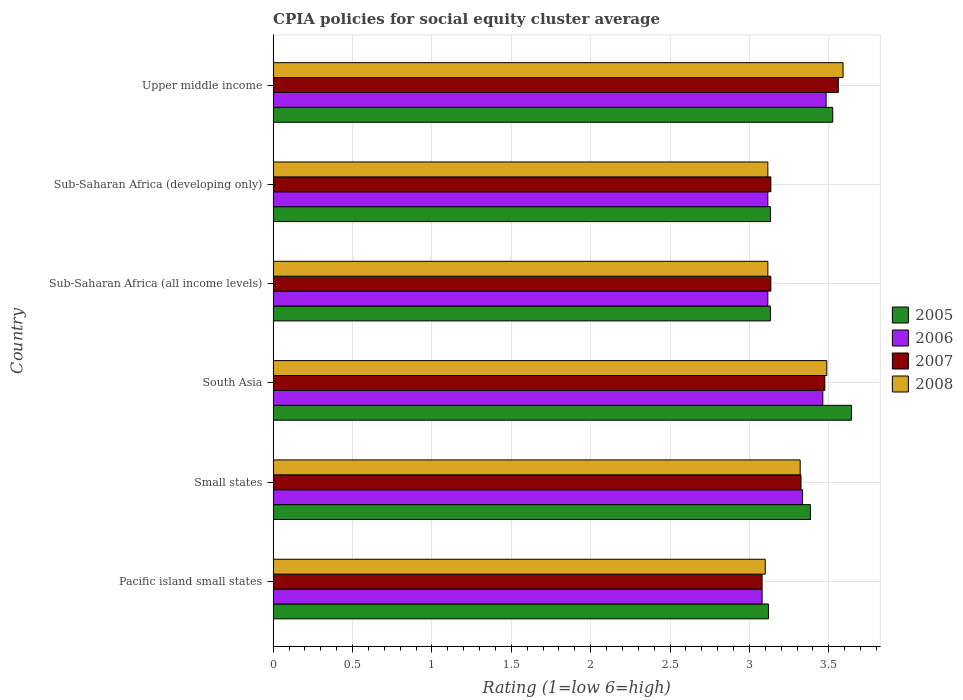How many different coloured bars are there?
Keep it short and to the point. 4. How many groups of bars are there?
Your answer should be compact. 6. Are the number of bars per tick equal to the number of legend labels?
Your response must be concise. Yes. How many bars are there on the 2nd tick from the top?
Give a very brief answer. 4. How many bars are there on the 5th tick from the bottom?
Offer a very short reply. 4. What is the label of the 1st group of bars from the top?
Provide a short and direct response. Upper middle income. What is the CPIA rating in 2007 in Small states?
Give a very brief answer. 3.33. Across all countries, what is the maximum CPIA rating in 2008?
Give a very brief answer. 3.59. Across all countries, what is the minimum CPIA rating in 2006?
Give a very brief answer. 3.08. In which country was the CPIA rating in 2006 maximum?
Offer a terse response. Upper middle income. In which country was the CPIA rating in 2005 minimum?
Make the answer very short. Pacific island small states. What is the total CPIA rating in 2005 in the graph?
Your answer should be very brief. 19.94. What is the difference between the CPIA rating in 2006 in Sub-Saharan Africa (developing only) and that in Upper middle income?
Make the answer very short. -0.37. What is the difference between the CPIA rating in 2005 in South Asia and the CPIA rating in 2006 in Sub-Saharan Africa (developing only)?
Ensure brevity in your answer.  0.53. What is the average CPIA rating in 2008 per country?
Provide a succinct answer. 3.29. What is the difference between the CPIA rating in 2005 and CPIA rating in 2008 in Small states?
Keep it short and to the point. 0.06. In how many countries, is the CPIA rating in 2006 greater than 2.7 ?
Your answer should be compact. 6. What is the ratio of the CPIA rating in 2005 in Small states to that in Sub-Saharan Africa (developing only)?
Ensure brevity in your answer.  1.08. Is the difference between the CPIA rating in 2005 in Pacific island small states and Upper middle income greater than the difference between the CPIA rating in 2008 in Pacific island small states and Upper middle income?
Give a very brief answer. Yes. What is the difference between the highest and the second highest CPIA rating in 2008?
Your answer should be very brief. 0.1. What is the difference between the highest and the lowest CPIA rating in 2005?
Your answer should be compact. 0.52. What does the 4th bar from the top in Pacific island small states represents?
Ensure brevity in your answer.  2005. How many countries are there in the graph?
Provide a short and direct response. 6. Does the graph contain any zero values?
Your response must be concise. No. Does the graph contain grids?
Provide a succinct answer. Yes. How are the legend labels stacked?
Offer a terse response. Vertical. What is the title of the graph?
Give a very brief answer. CPIA policies for social equity cluster average. Does "2003" appear as one of the legend labels in the graph?
Provide a succinct answer. No. What is the label or title of the Y-axis?
Provide a short and direct response. Country. What is the Rating (1=low 6=high) in 2005 in Pacific island small states?
Offer a terse response. 3.12. What is the Rating (1=low 6=high) in 2006 in Pacific island small states?
Ensure brevity in your answer.  3.08. What is the Rating (1=low 6=high) in 2007 in Pacific island small states?
Offer a very short reply. 3.08. What is the Rating (1=low 6=high) in 2005 in Small states?
Offer a terse response. 3.38. What is the Rating (1=low 6=high) in 2006 in Small states?
Offer a terse response. 3.33. What is the Rating (1=low 6=high) of 2007 in Small states?
Make the answer very short. 3.33. What is the Rating (1=low 6=high) in 2008 in Small states?
Keep it short and to the point. 3.32. What is the Rating (1=low 6=high) of 2005 in South Asia?
Ensure brevity in your answer.  3.64. What is the Rating (1=low 6=high) in 2006 in South Asia?
Keep it short and to the point. 3.46. What is the Rating (1=low 6=high) in 2007 in South Asia?
Your answer should be compact. 3.48. What is the Rating (1=low 6=high) of 2008 in South Asia?
Your answer should be very brief. 3.49. What is the Rating (1=low 6=high) of 2005 in Sub-Saharan Africa (all income levels)?
Provide a short and direct response. 3.13. What is the Rating (1=low 6=high) in 2006 in Sub-Saharan Africa (all income levels)?
Ensure brevity in your answer.  3.12. What is the Rating (1=low 6=high) of 2007 in Sub-Saharan Africa (all income levels)?
Offer a terse response. 3.14. What is the Rating (1=low 6=high) in 2008 in Sub-Saharan Africa (all income levels)?
Offer a terse response. 3.12. What is the Rating (1=low 6=high) in 2005 in Sub-Saharan Africa (developing only)?
Keep it short and to the point. 3.13. What is the Rating (1=low 6=high) of 2006 in Sub-Saharan Africa (developing only)?
Your answer should be compact. 3.12. What is the Rating (1=low 6=high) of 2007 in Sub-Saharan Africa (developing only)?
Offer a very short reply. 3.14. What is the Rating (1=low 6=high) in 2008 in Sub-Saharan Africa (developing only)?
Keep it short and to the point. 3.12. What is the Rating (1=low 6=high) of 2005 in Upper middle income?
Your response must be concise. 3.52. What is the Rating (1=low 6=high) in 2006 in Upper middle income?
Your answer should be compact. 3.48. What is the Rating (1=low 6=high) of 2007 in Upper middle income?
Your answer should be very brief. 3.56. What is the Rating (1=low 6=high) of 2008 in Upper middle income?
Give a very brief answer. 3.59. Across all countries, what is the maximum Rating (1=low 6=high) in 2005?
Make the answer very short. 3.64. Across all countries, what is the maximum Rating (1=low 6=high) in 2006?
Provide a short and direct response. 3.48. Across all countries, what is the maximum Rating (1=low 6=high) in 2007?
Provide a succinct answer. 3.56. Across all countries, what is the maximum Rating (1=low 6=high) in 2008?
Ensure brevity in your answer.  3.59. Across all countries, what is the minimum Rating (1=low 6=high) in 2005?
Give a very brief answer. 3.12. Across all countries, what is the minimum Rating (1=low 6=high) in 2006?
Provide a short and direct response. 3.08. Across all countries, what is the minimum Rating (1=low 6=high) of 2007?
Your response must be concise. 3.08. What is the total Rating (1=low 6=high) of 2005 in the graph?
Ensure brevity in your answer.  19.94. What is the total Rating (1=low 6=high) of 2006 in the graph?
Your answer should be compact. 19.59. What is the total Rating (1=low 6=high) in 2007 in the graph?
Give a very brief answer. 19.71. What is the total Rating (1=low 6=high) in 2008 in the graph?
Provide a short and direct response. 19.73. What is the difference between the Rating (1=low 6=high) in 2005 in Pacific island small states and that in Small states?
Keep it short and to the point. -0.26. What is the difference between the Rating (1=low 6=high) in 2006 in Pacific island small states and that in Small states?
Provide a succinct answer. -0.26. What is the difference between the Rating (1=low 6=high) in 2007 in Pacific island small states and that in Small states?
Offer a very short reply. -0.24. What is the difference between the Rating (1=low 6=high) in 2008 in Pacific island small states and that in Small states?
Your answer should be very brief. -0.22. What is the difference between the Rating (1=low 6=high) in 2005 in Pacific island small states and that in South Asia?
Offer a terse response. -0.52. What is the difference between the Rating (1=low 6=high) of 2006 in Pacific island small states and that in South Asia?
Provide a short and direct response. -0.38. What is the difference between the Rating (1=low 6=high) in 2007 in Pacific island small states and that in South Asia?
Give a very brief answer. -0.4. What is the difference between the Rating (1=low 6=high) of 2008 in Pacific island small states and that in South Asia?
Keep it short and to the point. -0.39. What is the difference between the Rating (1=low 6=high) of 2005 in Pacific island small states and that in Sub-Saharan Africa (all income levels)?
Your answer should be compact. -0.01. What is the difference between the Rating (1=low 6=high) in 2006 in Pacific island small states and that in Sub-Saharan Africa (all income levels)?
Ensure brevity in your answer.  -0.04. What is the difference between the Rating (1=low 6=high) of 2007 in Pacific island small states and that in Sub-Saharan Africa (all income levels)?
Offer a very short reply. -0.06. What is the difference between the Rating (1=low 6=high) in 2008 in Pacific island small states and that in Sub-Saharan Africa (all income levels)?
Provide a succinct answer. -0.02. What is the difference between the Rating (1=low 6=high) of 2005 in Pacific island small states and that in Sub-Saharan Africa (developing only)?
Your answer should be compact. -0.01. What is the difference between the Rating (1=low 6=high) in 2006 in Pacific island small states and that in Sub-Saharan Africa (developing only)?
Offer a terse response. -0.04. What is the difference between the Rating (1=low 6=high) in 2007 in Pacific island small states and that in Sub-Saharan Africa (developing only)?
Offer a terse response. -0.06. What is the difference between the Rating (1=low 6=high) of 2008 in Pacific island small states and that in Sub-Saharan Africa (developing only)?
Offer a very short reply. -0.02. What is the difference between the Rating (1=low 6=high) of 2005 in Pacific island small states and that in Upper middle income?
Give a very brief answer. -0.41. What is the difference between the Rating (1=low 6=high) in 2006 in Pacific island small states and that in Upper middle income?
Keep it short and to the point. -0.4. What is the difference between the Rating (1=low 6=high) of 2007 in Pacific island small states and that in Upper middle income?
Give a very brief answer. -0.48. What is the difference between the Rating (1=low 6=high) in 2008 in Pacific island small states and that in Upper middle income?
Provide a short and direct response. -0.49. What is the difference between the Rating (1=low 6=high) of 2005 in Small states and that in South Asia?
Your response must be concise. -0.26. What is the difference between the Rating (1=low 6=high) of 2006 in Small states and that in South Asia?
Ensure brevity in your answer.  -0.13. What is the difference between the Rating (1=low 6=high) in 2008 in Small states and that in South Asia?
Give a very brief answer. -0.17. What is the difference between the Rating (1=low 6=high) in 2005 in Small states and that in Sub-Saharan Africa (all income levels)?
Keep it short and to the point. 0.25. What is the difference between the Rating (1=low 6=high) in 2006 in Small states and that in Sub-Saharan Africa (all income levels)?
Provide a short and direct response. 0.22. What is the difference between the Rating (1=low 6=high) in 2007 in Small states and that in Sub-Saharan Africa (all income levels)?
Give a very brief answer. 0.19. What is the difference between the Rating (1=low 6=high) in 2008 in Small states and that in Sub-Saharan Africa (all income levels)?
Offer a very short reply. 0.2. What is the difference between the Rating (1=low 6=high) of 2005 in Small states and that in Sub-Saharan Africa (developing only)?
Keep it short and to the point. 0.25. What is the difference between the Rating (1=low 6=high) of 2006 in Small states and that in Sub-Saharan Africa (developing only)?
Make the answer very short. 0.22. What is the difference between the Rating (1=low 6=high) of 2007 in Small states and that in Sub-Saharan Africa (developing only)?
Provide a succinct answer. 0.19. What is the difference between the Rating (1=low 6=high) in 2008 in Small states and that in Sub-Saharan Africa (developing only)?
Your answer should be very brief. 0.2. What is the difference between the Rating (1=low 6=high) of 2005 in Small states and that in Upper middle income?
Your response must be concise. -0.14. What is the difference between the Rating (1=low 6=high) of 2006 in Small states and that in Upper middle income?
Give a very brief answer. -0.15. What is the difference between the Rating (1=low 6=high) of 2007 in Small states and that in Upper middle income?
Keep it short and to the point. -0.23. What is the difference between the Rating (1=low 6=high) of 2008 in Small states and that in Upper middle income?
Ensure brevity in your answer.  -0.27. What is the difference between the Rating (1=low 6=high) in 2005 in South Asia and that in Sub-Saharan Africa (all income levels)?
Provide a succinct answer. 0.51. What is the difference between the Rating (1=low 6=high) of 2006 in South Asia and that in Sub-Saharan Africa (all income levels)?
Your answer should be compact. 0.35. What is the difference between the Rating (1=low 6=high) in 2007 in South Asia and that in Sub-Saharan Africa (all income levels)?
Provide a short and direct response. 0.34. What is the difference between the Rating (1=low 6=high) in 2008 in South Asia and that in Sub-Saharan Africa (all income levels)?
Ensure brevity in your answer.  0.37. What is the difference between the Rating (1=low 6=high) of 2005 in South Asia and that in Sub-Saharan Africa (developing only)?
Keep it short and to the point. 0.51. What is the difference between the Rating (1=low 6=high) of 2006 in South Asia and that in Sub-Saharan Africa (developing only)?
Provide a short and direct response. 0.35. What is the difference between the Rating (1=low 6=high) of 2007 in South Asia and that in Sub-Saharan Africa (developing only)?
Your response must be concise. 0.34. What is the difference between the Rating (1=low 6=high) in 2008 in South Asia and that in Sub-Saharan Africa (developing only)?
Make the answer very short. 0.37. What is the difference between the Rating (1=low 6=high) in 2005 in South Asia and that in Upper middle income?
Your answer should be compact. 0.12. What is the difference between the Rating (1=low 6=high) in 2006 in South Asia and that in Upper middle income?
Your answer should be compact. -0.02. What is the difference between the Rating (1=low 6=high) of 2007 in South Asia and that in Upper middle income?
Make the answer very short. -0.09. What is the difference between the Rating (1=low 6=high) of 2008 in South Asia and that in Upper middle income?
Keep it short and to the point. -0.1. What is the difference between the Rating (1=low 6=high) in 2006 in Sub-Saharan Africa (all income levels) and that in Sub-Saharan Africa (developing only)?
Your answer should be very brief. 0. What is the difference between the Rating (1=low 6=high) in 2008 in Sub-Saharan Africa (all income levels) and that in Sub-Saharan Africa (developing only)?
Provide a short and direct response. 0. What is the difference between the Rating (1=low 6=high) of 2005 in Sub-Saharan Africa (all income levels) and that in Upper middle income?
Provide a short and direct response. -0.39. What is the difference between the Rating (1=low 6=high) of 2006 in Sub-Saharan Africa (all income levels) and that in Upper middle income?
Offer a terse response. -0.37. What is the difference between the Rating (1=low 6=high) of 2007 in Sub-Saharan Africa (all income levels) and that in Upper middle income?
Your answer should be very brief. -0.42. What is the difference between the Rating (1=low 6=high) in 2008 in Sub-Saharan Africa (all income levels) and that in Upper middle income?
Your response must be concise. -0.47. What is the difference between the Rating (1=low 6=high) of 2005 in Sub-Saharan Africa (developing only) and that in Upper middle income?
Provide a short and direct response. -0.39. What is the difference between the Rating (1=low 6=high) in 2006 in Sub-Saharan Africa (developing only) and that in Upper middle income?
Your answer should be compact. -0.37. What is the difference between the Rating (1=low 6=high) in 2007 in Sub-Saharan Africa (developing only) and that in Upper middle income?
Provide a short and direct response. -0.42. What is the difference between the Rating (1=low 6=high) of 2008 in Sub-Saharan Africa (developing only) and that in Upper middle income?
Offer a very short reply. -0.47. What is the difference between the Rating (1=low 6=high) in 2005 in Pacific island small states and the Rating (1=low 6=high) in 2006 in Small states?
Provide a short and direct response. -0.21. What is the difference between the Rating (1=low 6=high) in 2005 in Pacific island small states and the Rating (1=low 6=high) in 2007 in Small states?
Provide a short and direct response. -0.2. What is the difference between the Rating (1=low 6=high) in 2006 in Pacific island small states and the Rating (1=low 6=high) in 2007 in Small states?
Your answer should be compact. -0.24. What is the difference between the Rating (1=low 6=high) in 2006 in Pacific island small states and the Rating (1=low 6=high) in 2008 in Small states?
Provide a succinct answer. -0.24. What is the difference between the Rating (1=low 6=high) of 2007 in Pacific island small states and the Rating (1=low 6=high) of 2008 in Small states?
Keep it short and to the point. -0.24. What is the difference between the Rating (1=low 6=high) of 2005 in Pacific island small states and the Rating (1=low 6=high) of 2006 in South Asia?
Make the answer very short. -0.34. What is the difference between the Rating (1=low 6=high) of 2005 in Pacific island small states and the Rating (1=low 6=high) of 2007 in South Asia?
Ensure brevity in your answer.  -0.35. What is the difference between the Rating (1=low 6=high) of 2005 in Pacific island small states and the Rating (1=low 6=high) of 2008 in South Asia?
Keep it short and to the point. -0.37. What is the difference between the Rating (1=low 6=high) in 2006 in Pacific island small states and the Rating (1=low 6=high) in 2007 in South Asia?
Ensure brevity in your answer.  -0.4. What is the difference between the Rating (1=low 6=high) in 2006 in Pacific island small states and the Rating (1=low 6=high) in 2008 in South Asia?
Give a very brief answer. -0.41. What is the difference between the Rating (1=low 6=high) in 2007 in Pacific island small states and the Rating (1=low 6=high) in 2008 in South Asia?
Make the answer very short. -0.41. What is the difference between the Rating (1=low 6=high) of 2005 in Pacific island small states and the Rating (1=low 6=high) of 2006 in Sub-Saharan Africa (all income levels)?
Offer a terse response. 0. What is the difference between the Rating (1=low 6=high) of 2005 in Pacific island small states and the Rating (1=low 6=high) of 2007 in Sub-Saharan Africa (all income levels)?
Your response must be concise. -0.02. What is the difference between the Rating (1=low 6=high) in 2005 in Pacific island small states and the Rating (1=low 6=high) in 2008 in Sub-Saharan Africa (all income levels)?
Ensure brevity in your answer.  0. What is the difference between the Rating (1=low 6=high) in 2006 in Pacific island small states and the Rating (1=low 6=high) in 2007 in Sub-Saharan Africa (all income levels)?
Offer a very short reply. -0.06. What is the difference between the Rating (1=low 6=high) of 2006 in Pacific island small states and the Rating (1=low 6=high) of 2008 in Sub-Saharan Africa (all income levels)?
Give a very brief answer. -0.04. What is the difference between the Rating (1=low 6=high) in 2007 in Pacific island small states and the Rating (1=low 6=high) in 2008 in Sub-Saharan Africa (all income levels)?
Provide a short and direct response. -0.04. What is the difference between the Rating (1=low 6=high) in 2005 in Pacific island small states and the Rating (1=low 6=high) in 2006 in Sub-Saharan Africa (developing only)?
Your response must be concise. 0. What is the difference between the Rating (1=low 6=high) of 2005 in Pacific island small states and the Rating (1=low 6=high) of 2007 in Sub-Saharan Africa (developing only)?
Your answer should be compact. -0.02. What is the difference between the Rating (1=low 6=high) of 2005 in Pacific island small states and the Rating (1=low 6=high) of 2008 in Sub-Saharan Africa (developing only)?
Offer a very short reply. 0. What is the difference between the Rating (1=low 6=high) of 2006 in Pacific island small states and the Rating (1=low 6=high) of 2007 in Sub-Saharan Africa (developing only)?
Provide a succinct answer. -0.06. What is the difference between the Rating (1=low 6=high) in 2006 in Pacific island small states and the Rating (1=low 6=high) in 2008 in Sub-Saharan Africa (developing only)?
Your answer should be very brief. -0.04. What is the difference between the Rating (1=low 6=high) of 2007 in Pacific island small states and the Rating (1=low 6=high) of 2008 in Sub-Saharan Africa (developing only)?
Give a very brief answer. -0.04. What is the difference between the Rating (1=low 6=high) of 2005 in Pacific island small states and the Rating (1=low 6=high) of 2006 in Upper middle income?
Your response must be concise. -0.36. What is the difference between the Rating (1=low 6=high) in 2005 in Pacific island small states and the Rating (1=low 6=high) in 2007 in Upper middle income?
Make the answer very short. -0.44. What is the difference between the Rating (1=low 6=high) in 2005 in Pacific island small states and the Rating (1=low 6=high) in 2008 in Upper middle income?
Your answer should be very brief. -0.47. What is the difference between the Rating (1=low 6=high) of 2006 in Pacific island small states and the Rating (1=low 6=high) of 2007 in Upper middle income?
Your response must be concise. -0.48. What is the difference between the Rating (1=low 6=high) of 2006 in Pacific island small states and the Rating (1=low 6=high) of 2008 in Upper middle income?
Offer a terse response. -0.51. What is the difference between the Rating (1=low 6=high) in 2007 in Pacific island small states and the Rating (1=low 6=high) in 2008 in Upper middle income?
Your answer should be very brief. -0.51. What is the difference between the Rating (1=low 6=high) of 2005 in Small states and the Rating (1=low 6=high) of 2006 in South Asia?
Your answer should be very brief. -0.08. What is the difference between the Rating (1=low 6=high) of 2005 in Small states and the Rating (1=low 6=high) of 2007 in South Asia?
Offer a terse response. -0.09. What is the difference between the Rating (1=low 6=high) in 2005 in Small states and the Rating (1=low 6=high) in 2008 in South Asia?
Offer a terse response. -0.1. What is the difference between the Rating (1=low 6=high) in 2006 in Small states and the Rating (1=low 6=high) in 2007 in South Asia?
Provide a short and direct response. -0.14. What is the difference between the Rating (1=low 6=high) in 2006 in Small states and the Rating (1=low 6=high) in 2008 in South Asia?
Provide a succinct answer. -0.15. What is the difference between the Rating (1=low 6=high) in 2007 in Small states and the Rating (1=low 6=high) in 2008 in South Asia?
Offer a very short reply. -0.16. What is the difference between the Rating (1=low 6=high) in 2005 in Small states and the Rating (1=low 6=high) in 2006 in Sub-Saharan Africa (all income levels)?
Your response must be concise. 0.27. What is the difference between the Rating (1=low 6=high) of 2005 in Small states and the Rating (1=low 6=high) of 2007 in Sub-Saharan Africa (all income levels)?
Offer a very short reply. 0.25. What is the difference between the Rating (1=low 6=high) in 2005 in Small states and the Rating (1=low 6=high) in 2008 in Sub-Saharan Africa (all income levels)?
Give a very brief answer. 0.27. What is the difference between the Rating (1=low 6=high) in 2006 in Small states and the Rating (1=low 6=high) in 2007 in Sub-Saharan Africa (all income levels)?
Offer a very short reply. 0.2. What is the difference between the Rating (1=low 6=high) in 2006 in Small states and the Rating (1=low 6=high) in 2008 in Sub-Saharan Africa (all income levels)?
Give a very brief answer. 0.22. What is the difference between the Rating (1=low 6=high) in 2007 in Small states and the Rating (1=low 6=high) in 2008 in Sub-Saharan Africa (all income levels)?
Offer a very short reply. 0.21. What is the difference between the Rating (1=low 6=high) of 2005 in Small states and the Rating (1=low 6=high) of 2006 in Sub-Saharan Africa (developing only)?
Provide a succinct answer. 0.27. What is the difference between the Rating (1=low 6=high) in 2005 in Small states and the Rating (1=low 6=high) in 2007 in Sub-Saharan Africa (developing only)?
Make the answer very short. 0.25. What is the difference between the Rating (1=low 6=high) of 2005 in Small states and the Rating (1=low 6=high) of 2008 in Sub-Saharan Africa (developing only)?
Keep it short and to the point. 0.27. What is the difference between the Rating (1=low 6=high) of 2006 in Small states and the Rating (1=low 6=high) of 2007 in Sub-Saharan Africa (developing only)?
Keep it short and to the point. 0.2. What is the difference between the Rating (1=low 6=high) in 2006 in Small states and the Rating (1=low 6=high) in 2008 in Sub-Saharan Africa (developing only)?
Give a very brief answer. 0.22. What is the difference between the Rating (1=low 6=high) of 2007 in Small states and the Rating (1=low 6=high) of 2008 in Sub-Saharan Africa (developing only)?
Keep it short and to the point. 0.21. What is the difference between the Rating (1=low 6=high) of 2005 in Small states and the Rating (1=low 6=high) of 2006 in Upper middle income?
Provide a succinct answer. -0.1. What is the difference between the Rating (1=low 6=high) in 2005 in Small states and the Rating (1=low 6=high) in 2007 in Upper middle income?
Make the answer very short. -0.18. What is the difference between the Rating (1=low 6=high) of 2005 in Small states and the Rating (1=low 6=high) of 2008 in Upper middle income?
Provide a succinct answer. -0.21. What is the difference between the Rating (1=low 6=high) in 2006 in Small states and the Rating (1=low 6=high) in 2007 in Upper middle income?
Your answer should be very brief. -0.23. What is the difference between the Rating (1=low 6=high) of 2006 in Small states and the Rating (1=low 6=high) of 2008 in Upper middle income?
Offer a terse response. -0.26. What is the difference between the Rating (1=low 6=high) in 2007 in Small states and the Rating (1=low 6=high) in 2008 in Upper middle income?
Ensure brevity in your answer.  -0.27. What is the difference between the Rating (1=low 6=high) of 2005 in South Asia and the Rating (1=low 6=high) of 2006 in Sub-Saharan Africa (all income levels)?
Give a very brief answer. 0.53. What is the difference between the Rating (1=low 6=high) of 2005 in South Asia and the Rating (1=low 6=high) of 2007 in Sub-Saharan Africa (all income levels)?
Offer a very short reply. 0.51. What is the difference between the Rating (1=low 6=high) of 2005 in South Asia and the Rating (1=low 6=high) of 2008 in Sub-Saharan Africa (all income levels)?
Your answer should be compact. 0.53. What is the difference between the Rating (1=low 6=high) in 2006 in South Asia and the Rating (1=low 6=high) in 2007 in Sub-Saharan Africa (all income levels)?
Your response must be concise. 0.33. What is the difference between the Rating (1=low 6=high) of 2006 in South Asia and the Rating (1=low 6=high) of 2008 in Sub-Saharan Africa (all income levels)?
Your answer should be compact. 0.35. What is the difference between the Rating (1=low 6=high) in 2007 in South Asia and the Rating (1=low 6=high) in 2008 in Sub-Saharan Africa (all income levels)?
Ensure brevity in your answer.  0.36. What is the difference between the Rating (1=low 6=high) in 2005 in South Asia and the Rating (1=low 6=high) in 2006 in Sub-Saharan Africa (developing only)?
Offer a terse response. 0.53. What is the difference between the Rating (1=low 6=high) of 2005 in South Asia and the Rating (1=low 6=high) of 2007 in Sub-Saharan Africa (developing only)?
Provide a short and direct response. 0.51. What is the difference between the Rating (1=low 6=high) of 2005 in South Asia and the Rating (1=low 6=high) of 2008 in Sub-Saharan Africa (developing only)?
Provide a short and direct response. 0.53. What is the difference between the Rating (1=low 6=high) in 2006 in South Asia and the Rating (1=low 6=high) in 2007 in Sub-Saharan Africa (developing only)?
Your answer should be compact. 0.33. What is the difference between the Rating (1=low 6=high) in 2006 in South Asia and the Rating (1=low 6=high) in 2008 in Sub-Saharan Africa (developing only)?
Your answer should be very brief. 0.35. What is the difference between the Rating (1=low 6=high) in 2007 in South Asia and the Rating (1=low 6=high) in 2008 in Sub-Saharan Africa (developing only)?
Offer a terse response. 0.36. What is the difference between the Rating (1=low 6=high) of 2005 in South Asia and the Rating (1=low 6=high) of 2006 in Upper middle income?
Ensure brevity in your answer.  0.16. What is the difference between the Rating (1=low 6=high) of 2005 in South Asia and the Rating (1=low 6=high) of 2007 in Upper middle income?
Give a very brief answer. 0.08. What is the difference between the Rating (1=low 6=high) of 2005 in South Asia and the Rating (1=low 6=high) of 2008 in Upper middle income?
Provide a short and direct response. 0.05. What is the difference between the Rating (1=low 6=high) of 2006 in South Asia and the Rating (1=low 6=high) of 2007 in Upper middle income?
Offer a very short reply. -0.1. What is the difference between the Rating (1=low 6=high) of 2006 in South Asia and the Rating (1=low 6=high) of 2008 in Upper middle income?
Your response must be concise. -0.13. What is the difference between the Rating (1=low 6=high) in 2007 in South Asia and the Rating (1=low 6=high) in 2008 in Upper middle income?
Ensure brevity in your answer.  -0.12. What is the difference between the Rating (1=low 6=high) in 2005 in Sub-Saharan Africa (all income levels) and the Rating (1=low 6=high) in 2006 in Sub-Saharan Africa (developing only)?
Your answer should be compact. 0.02. What is the difference between the Rating (1=low 6=high) of 2005 in Sub-Saharan Africa (all income levels) and the Rating (1=low 6=high) of 2007 in Sub-Saharan Africa (developing only)?
Ensure brevity in your answer.  -0. What is the difference between the Rating (1=low 6=high) of 2005 in Sub-Saharan Africa (all income levels) and the Rating (1=low 6=high) of 2008 in Sub-Saharan Africa (developing only)?
Offer a terse response. 0.02. What is the difference between the Rating (1=low 6=high) in 2006 in Sub-Saharan Africa (all income levels) and the Rating (1=low 6=high) in 2007 in Sub-Saharan Africa (developing only)?
Make the answer very short. -0.02. What is the difference between the Rating (1=low 6=high) of 2007 in Sub-Saharan Africa (all income levels) and the Rating (1=low 6=high) of 2008 in Sub-Saharan Africa (developing only)?
Provide a succinct answer. 0.02. What is the difference between the Rating (1=low 6=high) in 2005 in Sub-Saharan Africa (all income levels) and the Rating (1=low 6=high) in 2006 in Upper middle income?
Your response must be concise. -0.35. What is the difference between the Rating (1=low 6=high) in 2005 in Sub-Saharan Africa (all income levels) and the Rating (1=low 6=high) in 2007 in Upper middle income?
Your answer should be very brief. -0.43. What is the difference between the Rating (1=low 6=high) of 2005 in Sub-Saharan Africa (all income levels) and the Rating (1=low 6=high) of 2008 in Upper middle income?
Offer a very short reply. -0.46. What is the difference between the Rating (1=low 6=high) in 2006 in Sub-Saharan Africa (all income levels) and the Rating (1=low 6=high) in 2007 in Upper middle income?
Make the answer very short. -0.44. What is the difference between the Rating (1=low 6=high) of 2006 in Sub-Saharan Africa (all income levels) and the Rating (1=low 6=high) of 2008 in Upper middle income?
Provide a short and direct response. -0.47. What is the difference between the Rating (1=low 6=high) of 2007 in Sub-Saharan Africa (all income levels) and the Rating (1=low 6=high) of 2008 in Upper middle income?
Give a very brief answer. -0.45. What is the difference between the Rating (1=low 6=high) of 2005 in Sub-Saharan Africa (developing only) and the Rating (1=low 6=high) of 2006 in Upper middle income?
Your response must be concise. -0.35. What is the difference between the Rating (1=low 6=high) in 2005 in Sub-Saharan Africa (developing only) and the Rating (1=low 6=high) in 2007 in Upper middle income?
Offer a terse response. -0.43. What is the difference between the Rating (1=low 6=high) of 2005 in Sub-Saharan Africa (developing only) and the Rating (1=low 6=high) of 2008 in Upper middle income?
Provide a succinct answer. -0.46. What is the difference between the Rating (1=low 6=high) in 2006 in Sub-Saharan Africa (developing only) and the Rating (1=low 6=high) in 2007 in Upper middle income?
Offer a very short reply. -0.44. What is the difference between the Rating (1=low 6=high) of 2006 in Sub-Saharan Africa (developing only) and the Rating (1=low 6=high) of 2008 in Upper middle income?
Provide a succinct answer. -0.47. What is the difference between the Rating (1=low 6=high) in 2007 in Sub-Saharan Africa (developing only) and the Rating (1=low 6=high) in 2008 in Upper middle income?
Offer a very short reply. -0.45. What is the average Rating (1=low 6=high) in 2005 per country?
Your answer should be very brief. 3.32. What is the average Rating (1=low 6=high) in 2006 per country?
Offer a very short reply. 3.27. What is the average Rating (1=low 6=high) in 2007 per country?
Provide a succinct answer. 3.29. What is the average Rating (1=low 6=high) of 2008 per country?
Your answer should be very brief. 3.29. What is the difference between the Rating (1=low 6=high) in 2005 and Rating (1=low 6=high) in 2007 in Pacific island small states?
Keep it short and to the point. 0.04. What is the difference between the Rating (1=low 6=high) of 2006 and Rating (1=low 6=high) of 2008 in Pacific island small states?
Make the answer very short. -0.02. What is the difference between the Rating (1=low 6=high) of 2007 and Rating (1=low 6=high) of 2008 in Pacific island small states?
Make the answer very short. -0.02. What is the difference between the Rating (1=low 6=high) of 2005 and Rating (1=low 6=high) of 2006 in Small states?
Offer a very short reply. 0.05. What is the difference between the Rating (1=low 6=high) in 2005 and Rating (1=low 6=high) in 2007 in Small states?
Provide a succinct answer. 0.06. What is the difference between the Rating (1=low 6=high) in 2005 and Rating (1=low 6=high) in 2008 in Small states?
Make the answer very short. 0.06. What is the difference between the Rating (1=low 6=high) of 2006 and Rating (1=low 6=high) of 2008 in Small states?
Provide a succinct answer. 0.01. What is the difference between the Rating (1=low 6=high) of 2007 and Rating (1=low 6=high) of 2008 in Small states?
Offer a very short reply. 0.01. What is the difference between the Rating (1=low 6=high) in 2005 and Rating (1=low 6=high) in 2006 in South Asia?
Give a very brief answer. 0.18. What is the difference between the Rating (1=low 6=high) of 2005 and Rating (1=low 6=high) of 2007 in South Asia?
Offer a very short reply. 0.17. What is the difference between the Rating (1=low 6=high) of 2005 and Rating (1=low 6=high) of 2008 in South Asia?
Make the answer very short. 0.16. What is the difference between the Rating (1=low 6=high) of 2006 and Rating (1=low 6=high) of 2007 in South Asia?
Give a very brief answer. -0.01. What is the difference between the Rating (1=low 6=high) of 2006 and Rating (1=low 6=high) of 2008 in South Asia?
Provide a short and direct response. -0.03. What is the difference between the Rating (1=low 6=high) in 2007 and Rating (1=low 6=high) in 2008 in South Asia?
Your response must be concise. -0.01. What is the difference between the Rating (1=low 6=high) of 2005 and Rating (1=low 6=high) of 2006 in Sub-Saharan Africa (all income levels)?
Your answer should be very brief. 0.02. What is the difference between the Rating (1=low 6=high) in 2005 and Rating (1=low 6=high) in 2007 in Sub-Saharan Africa (all income levels)?
Provide a short and direct response. -0. What is the difference between the Rating (1=low 6=high) in 2005 and Rating (1=low 6=high) in 2008 in Sub-Saharan Africa (all income levels)?
Your response must be concise. 0.02. What is the difference between the Rating (1=low 6=high) of 2006 and Rating (1=low 6=high) of 2007 in Sub-Saharan Africa (all income levels)?
Provide a succinct answer. -0.02. What is the difference between the Rating (1=low 6=high) of 2006 and Rating (1=low 6=high) of 2008 in Sub-Saharan Africa (all income levels)?
Make the answer very short. 0. What is the difference between the Rating (1=low 6=high) in 2007 and Rating (1=low 6=high) in 2008 in Sub-Saharan Africa (all income levels)?
Provide a succinct answer. 0.02. What is the difference between the Rating (1=low 6=high) of 2005 and Rating (1=low 6=high) of 2006 in Sub-Saharan Africa (developing only)?
Your answer should be very brief. 0.02. What is the difference between the Rating (1=low 6=high) of 2005 and Rating (1=low 6=high) of 2007 in Sub-Saharan Africa (developing only)?
Make the answer very short. -0. What is the difference between the Rating (1=low 6=high) in 2005 and Rating (1=low 6=high) in 2008 in Sub-Saharan Africa (developing only)?
Provide a succinct answer. 0.02. What is the difference between the Rating (1=low 6=high) of 2006 and Rating (1=low 6=high) of 2007 in Sub-Saharan Africa (developing only)?
Offer a terse response. -0.02. What is the difference between the Rating (1=low 6=high) of 2007 and Rating (1=low 6=high) of 2008 in Sub-Saharan Africa (developing only)?
Ensure brevity in your answer.  0.02. What is the difference between the Rating (1=low 6=high) in 2005 and Rating (1=low 6=high) in 2006 in Upper middle income?
Provide a succinct answer. 0.04. What is the difference between the Rating (1=low 6=high) in 2005 and Rating (1=low 6=high) in 2007 in Upper middle income?
Give a very brief answer. -0.04. What is the difference between the Rating (1=low 6=high) of 2005 and Rating (1=low 6=high) of 2008 in Upper middle income?
Offer a very short reply. -0.07. What is the difference between the Rating (1=low 6=high) in 2006 and Rating (1=low 6=high) in 2007 in Upper middle income?
Your answer should be compact. -0.08. What is the difference between the Rating (1=low 6=high) in 2006 and Rating (1=low 6=high) in 2008 in Upper middle income?
Offer a very short reply. -0.11. What is the difference between the Rating (1=low 6=high) of 2007 and Rating (1=low 6=high) of 2008 in Upper middle income?
Keep it short and to the point. -0.03. What is the ratio of the Rating (1=low 6=high) of 2005 in Pacific island small states to that in Small states?
Give a very brief answer. 0.92. What is the ratio of the Rating (1=low 6=high) in 2006 in Pacific island small states to that in Small states?
Keep it short and to the point. 0.92. What is the ratio of the Rating (1=low 6=high) in 2007 in Pacific island small states to that in Small states?
Ensure brevity in your answer.  0.93. What is the ratio of the Rating (1=low 6=high) of 2008 in Pacific island small states to that in Small states?
Make the answer very short. 0.93. What is the ratio of the Rating (1=low 6=high) in 2005 in Pacific island small states to that in South Asia?
Offer a terse response. 0.86. What is the ratio of the Rating (1=low 6=high) in 2006 in Pacific island small states to that in South Asia?
Your response must be concise. 0.89. What is the ratio of the Rating (1=low 6=high) of 2007 in Pacific island small states to that in South Asia?
Provide a succinct answer. 0.89. What is the ratio of the Rating (1=low 6=high) in 2008 in Pacific island small states to that in South Asia?
Provide a short and direct response. 0.89. What is the ratio of the Rating (1=low 6=high) in 2006 in Pacific island small states to that in Sub-Saharan Africa (all income levels)?
Your answer should be compact. 0.99. What is the ratio of the Rating (1=low 6=high) of 2007 in Pacific island small states to that in Sub-Saharan Africa (all income levels)?
Your answer should be compact. 0.98. What is the ratio of the Rating (1=low 6=high) in 2008 in Pacific island small states to that in Sub-Saharan Africa (all income levels)?
Provide a short and direct response. 0.99. What is the ratio of the Rating (1=low 6=high) of 2006 in Pacific island small states to that in Sub-Saharan Africa (developing only)?
Ensure brevity in your answer.  0.99. What is the ratio of the Rating (1=low 6=high) in 2007 in Pacific island small states to that in Sub-Saharan Africa (developing only)?
Your answer should be very brief. 0.98. What is the ratio of the Rating (1=low 6=high) of 2005 in Pacific island small states to that in Upper middle income?
Your answer should be very brief. 0.89. What is the ratio of the Rating (1=low 6=high) in 2006 in Pacific island small states to that in Upper middle income?
Offer a terse response. 0.88. What is the ratio of the Rating (1=low 6=high) in 2007 in Pacific island small states to that in Upper middle income?
Ensure brevity in your answer.  0.87. What is the ratio of the Rating (1=low 6=high) of 2008 in Pacific island small states to that in Upper middle income?
Ensure brevity in your answer.  0.86. What is the ratio of the Rating (1=low 6=high) in 2005 in Small states to that in South Asia?
Your answer should be very brief. 0.93. What is the ratio of the Rating (1=low 6=high) in 2006 in Small states to that in South Asia?
Offer a very short reply. 0.96. What is the ratio of the Rating (1=low 6=high) in 2007 in Small states to that in South Asia?
Offer a terse response. 0.96. What is the ratio of the Rating (1=low 6=high) in 2008 in Small states to that in South Asia?
Offer a very short reply. 0.95. What is the ratio of the Rating (1=low 6=high) in 2005 in Small states to that in Sub-Saharan Africa (all income levels)?
Make the answer very short. 1.08. What is the ratio of the Rating (1=low 6=high) of 2006 in Small states to that in Sub-Saharan Africa (all income levels)?
Offer a terse response. 1.07. What is the ratio of the Rating (1=low 6=high) of 2007 in Small states to that in Sub-Saharan Africa (all income levels)?
Provide a succinct answer. 1.06. What is the ratio of the Rating (1=low 6=high) of 2008 in Small states to that in Sub-Saharan Africa (all income levels)?
Provide a short and direct response. 1.07. What is the ratio of the Rating (1=low 6=high) in 2005 in Small states to that in Sub-Saharan Africa (developing only)?
Provide a succinct answer. 1.08. What is the ratio of the Rating (1=low 6=high) in 2006 in Small states to that in Sub-Saharan Africa (developing only)?
Ensure brevity in your answer.  1.07. What is the ratio of the Rating (1=low 6=high) in 2007 in Small states to that in Sub-Saharan Africa (developing only)?
Offer a very short reply. 1.06. What is the ratio of the Rating (1=low 6=high) of 2008 in Small states to that in Sub-Saharan Africa (developing only)?
Keep it short and to the point. 1.07. What is the ratio of the Rating (1=low 6=high) of 2005 in Small states to that in Upper middle income?
Your answer should be very brief. 0.96. What is the ratio of the Rating (1=low 6=high) of 2006 in Small states to that in Upper middle income?
Your response must be concise. 0.96. What is the ratio of the Rating (1=low 6=high) in 2007 in Small states to that in Upper middle income?
Keep it short and to the point. 0.93. What is the ratio of the Rating (1=low 6=high) of 2008 in Small states to that in Upper middle income?
Offer a terse response. 0.92. What is the ratio of the Rating (1=low 6=high) of 2005 in South Asia to that in Sub-Saharan Africa (all income levels)?
Offer a very short reply. 1.16. What is the ratio of the Rating (1=low 6=high) of 2006 in South Asia to that in Sub-Saharan Africa (all income levels)?
Your answer should be compact. 1.11. What is the ratio of the Rating (1=low 6=high) of 2007 in South Asia to that in Sub-Saharan Africa (all income levels)?
Provide a succinct answer. 1.11. What is the ratio of the Rating (1=low 6=high) of 2008 in South Asia to that in Sub-Saharan Africa (all income levels)?
Offer a very short reply. 1.12. What is the ratio of the Rating (1=low 6=high) of 2005 in South Asia to that in Sub-Saharan Africa (developing only)?
Provide a succinct answer. 1.16. What is the ratio of the Rating (1=low 6=high) of 2007 in South Asia to that in Sub-Saharan Africa (developing only)?
Ensure brevity in your answer.  1.11. What is the ratio of the Rating (1=low 6=high) of 2008 in South Asia to that in Sub-Saharan Africa (developing only)?
Keep it short and to the point. 1.12. What is the ratio of the Rating (1=low 6=high) in 2005 in South Asia to that in Upper middle income?
Provide a short and direct response. 1.03. What is the ratio of the Rating (1=low 6=high) of 2007 in South Asia to that in Upper middle income?
Your answer should be compact. 0.98. What is the ratio of the Rating (1=low 6=high) of 2008 in South Asia to that in Upper middle income?
Your answer should be very brief. 0.97. What is the ratio of the Rating (1=low 6=high) in 2005 in Sub-Saharan Africa (all income levels) to that in Sub-Saharan Africa (developing only)?
Provide a short and direct response. 1. What is the ratio of the Rating (1=low 6=high) in 2006 in Sub-Saharan Africa (all income levels) to that in Sub-Saharan Africa (developing only)?
Your answer should be very brief. 1. What is the ratio of the Rating (1=low 6=high) in 2007 in Sub-Saharan Africa (all income levels) to that in Sub-Saharan Africa (developing only)?
Ensure brevity in your answer.  1. What is the ratio of the Rating (1=low 6=high) of 2005 in Sub-Saharan Africa (all income levels) to that in Upper middle income?
Your answer should be very brief. 0.89. What is the ratio of the Rating (1=low 6=high) of 2006 in Sub-Saharan Africa (all income levels) to that in Upper middle income?
Provide a succinct answer. 0.89. What is the ratio of the Rating (1=low 6=high) in 2007 in Sub-Saharan Africa (all income levels) to that in Upper middle income?
Keep it short and to the point. 0.88. What is the ratio of the Rating (1=low 6=high) in 2008 in Sub-Saharan Africa (all income levels) to that in Upper middle income?
Make the answer very short. 0.87. What is the ratio of the Rating (1=low 6=high) of 2005 in Sub-Saharan Africa (developing only) to that in Upper middle income?
Your answer should be compact. 0.89. What is the ratio of the Rating (1=low 6=high) in 2006 in Sub-Saharan Africa (developing only) to that in Upper middle income?
Your response must be concise. 0.89. What is the ratio of the Rating (1=low 6=high) in 2007 in Sub-Saharan Africa (developing only) to that in Upper middle income?
Offer a terse response. 0.88. What is the ratio of the Rating (1=low 6=high) of 2008 in Sub-Saharan Africa (developing only) to that in Upper middle income?
Ensure brevity in your answer.  0.87. What is the difference between the highest and the second highest Rating (1=low 6=high) of 2005?
Give a very brief answer. 0.12. What is the difference between the highest and the second highest Rating (1=low 6=high) of 2006?
Your answer should be very brief. 0.02. What is the difference between the highest and the second highest Rating (1=low 6=high) in 2007?
Provide a short and direct response. 0.09. What is the difference between the highest and the second highest Rating (1=low 6=high) of 2008?
Provide a succinct answer. 0.1. What is the difference between the highest and the lowest Rating (1=low 6=high) in 2005?
Offer a very short reply. 0.52. What is the difference between the highest and the lowest Rating (1=low 6=high) of 2006?
Provide a short and direct response. 0.4. What is the difference between the highest and the lowest Rating (1=low 6=high) of 2007?
Your answer should be very brief. 0.48. What is the difference between the highest and the lowest Rating (1=low 6=high) of 2008?
Provide a short and direct response. 0.49. 